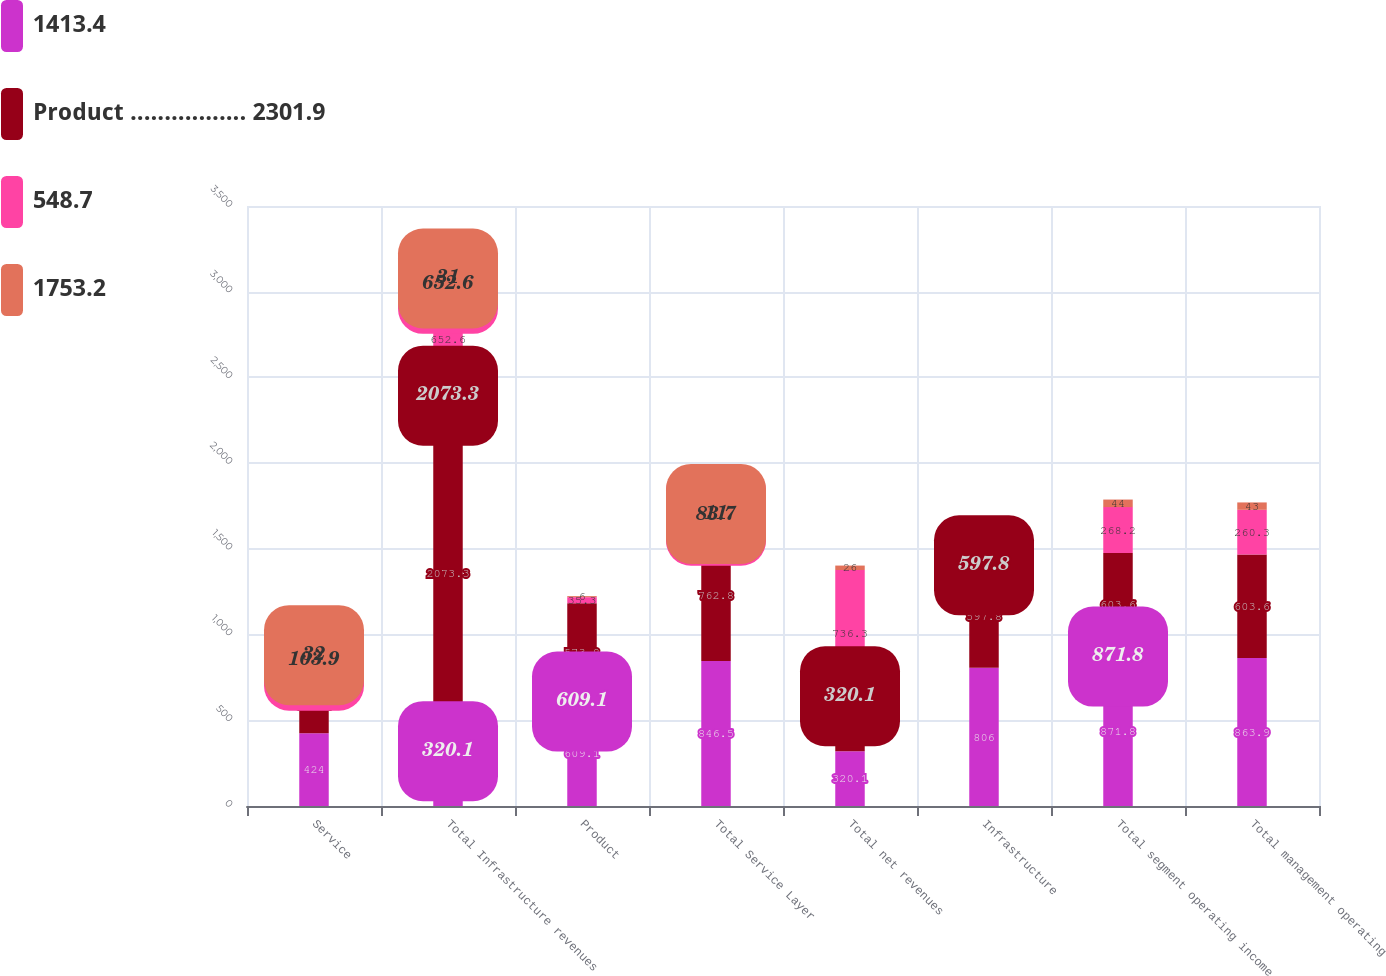<chart> <loc_0><loc_0><loc_500><loc_500><stacked_bar_chart><ecel><fcel>Service<fcel>Total Infrastructure revenues<fcel>Product<fcel>Total Service Layer<fcel>Total net revenues<fcel>Infrastructure<fcel>Total segment operating income<fcel>Total management operating<nl><fcel>1413.4<fcel>424<fcel>320.1<fcel>609.1<fcel>846.5<fcel>320.1<fcel>806<fcel>871.8<fcel>863.9<nl><fcel>Product ................. 2301.9<fcel>320.1<fcel>2073.3<fcel>573.8<fcel>762.8<fcel>320.1<fcel>597.8<fcel>603.6<fcel>603.6<nl><fcel>548.7<fcel>103.9<fcel>652.6<fcel>35.3<fcel>83.7<fcel>736.3<fcel>208.2<fcel>268.2<fcel>260.3<nl><fcel>1753.2<fcel>32<fcel>31<fcel>6<fcel>11<fcel>26<fcel>35<fcel>44<fcel>43<nl></chart> 